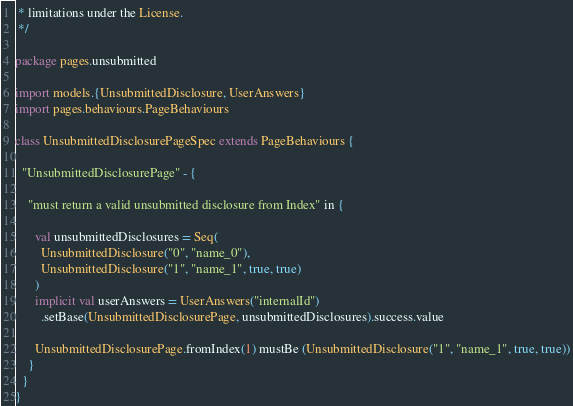Convert code to text. <code><loc_0><loc_0><loc_500><loc_500><_Scala_> * limitations under the License.
 */

package pages.unsubmitted

import models.{UnsubmittedDisclosure, UserAnswers}
import pages.behaviours.PageBehaviours

class UnsubmittedDisclosurePageSpec extends PageBehaviours {

  "UnsubmittedDisclosurePage" - {

    "must return a valid unsubmitted disclosure from Index" in {

      val unsubmittedDisclosures = Seq(
        UnsubmittedDisclosure("0", "name_0"),
        UnsubmittedDisclosure("1", "name_1", true, true)
      )
      implicit val userAnswers = UserAnswers("internalId")
        .setBase(UnsubmittedDisclosurePage, unsubmittedDisclosures).success.value

      UnsubmittedDisclosurePage.fromIndex(1) mustBe (UnsubmittedDisclosure("1", "name_1", true, true))
    }
  }
}</code> 